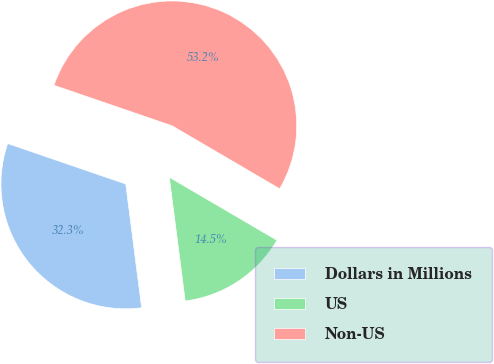Convert chart. <chart><loc_0><loc_0><loc_500><loc_500><pie_chart><fcel>Dollars in Millions<fcel>US<fcel>Non-US<nl><fcel>32.29%<fcel>14.54%<fcel>53.17%<nl></chart> 